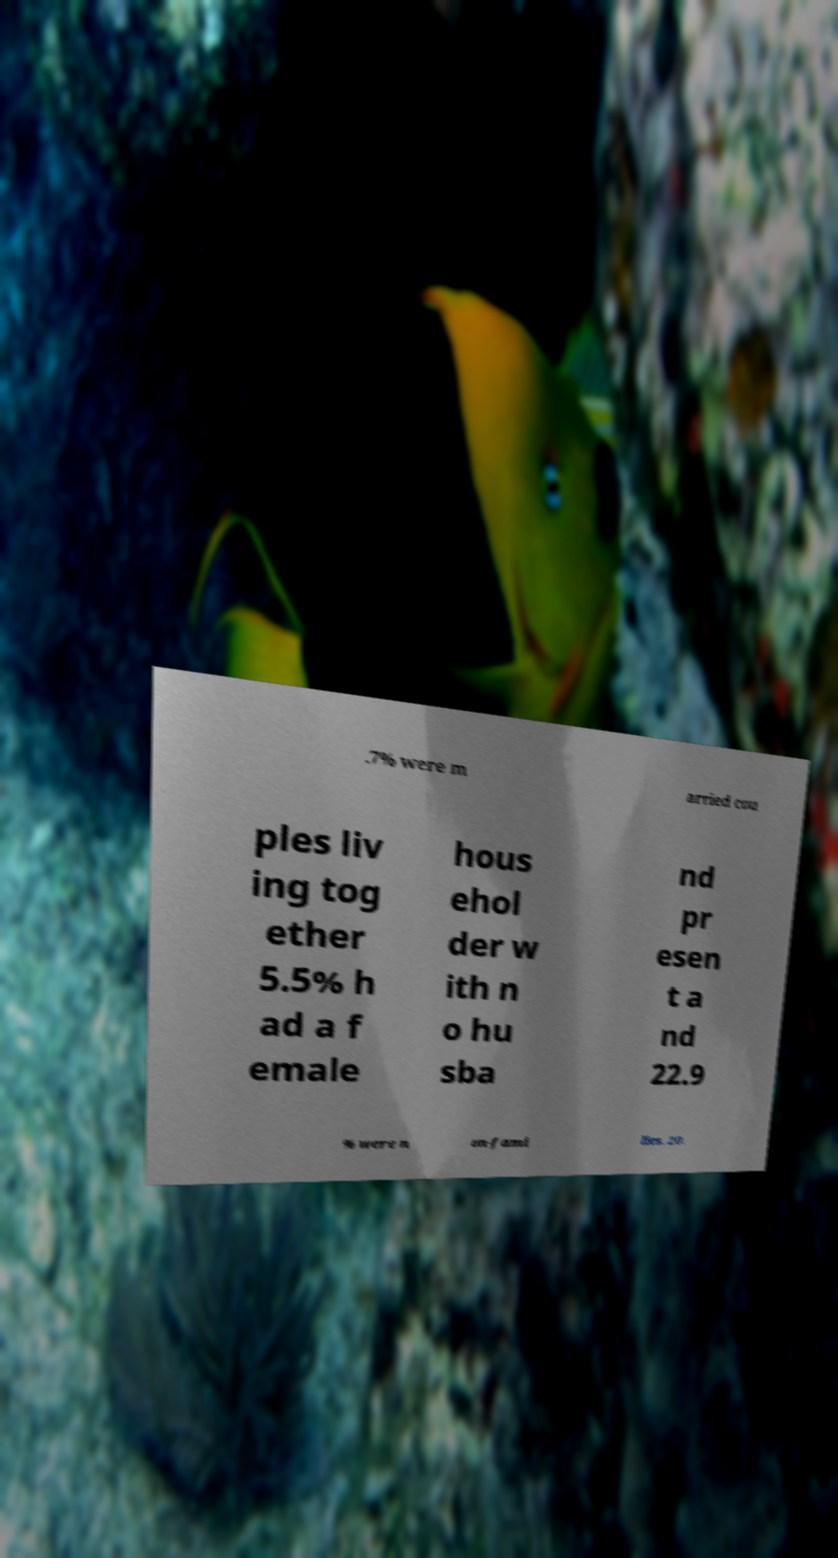For documentation purposes, I need the text within this image transcribed. Could you provide that? .7% were m arried cou ples liv ing tog ether 5.5% h ad a f emale hous ehol der w ith n o hu sba nd pr esen t a nd 22.9 % were n on-fami lies. 20. 